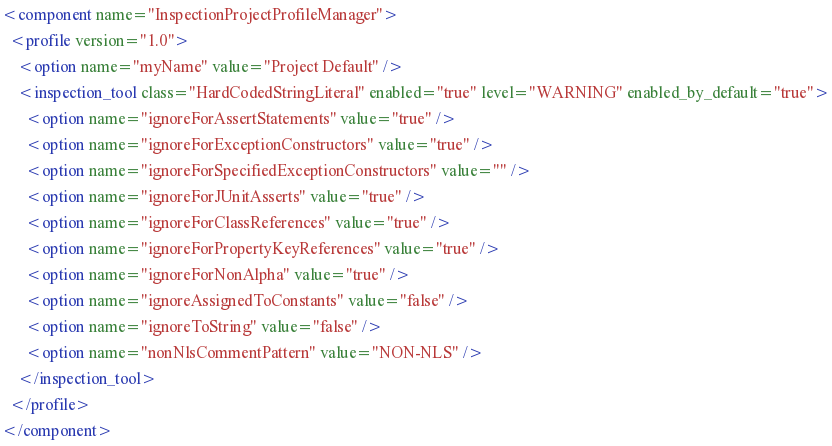Convert code to text. <code><loc_0><loc_0><loc_500><loc_500><_XML_><component name="InspectionProjectProfileManager">
  <profile version="1.0">
    <option name="myName" value="Project Default" />
    <inspection_tool class="HardCodedStringLiteral" enabled="true" level="WARNING" enabled_by_default="true">
      <option name="ignoreForAssertStatements" value="true" />
      <option name="ignoreForExceptionConstructors" value="true" />
      <option name="ignoreForSpecifiedExceptionConstructors" value="" />
      <option name="ignoreForJUnitAsserts" value="true" />
      <option name="ignoreForClassReferences" value="true" />
      <option name="ignoreForPropertyKeyReferences" value="true" />
      <option name="ignoreForNonAlpha" value="true" />
      <option name="ignoreAssignedToConstants" value="false" />
      <option name="ignoreToString" value="false" />
      <option name="nonNlsCommentPattern" value="NON-NLS" />
    </inspection_tool>
  </profile>
</component></code> 